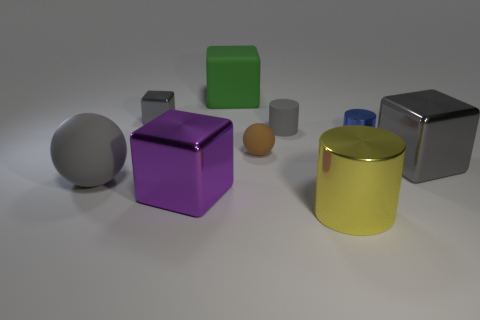Is the material of the small brown thing the same as the big gray thing right of the brown rubber thing?
Your answer should be compact. No. How big is the gray metal thing that is in front of the gray matte cylinder?
Offer a terse response. Large. Is the number of cyan shiny cylinders less than the number of large gray cubes?
Your response must be concise. Yes. Is there a tiny cylinder of the same color as the large rubber block?
Give a very brief answer. No. There is a big shiny object that is both on the left side of the tiny blue cylinder and behind the big yellow thing; what shape is it?
Make the answer very short. Cube. What is the shape of the big gray object behind the matte object that is to the left of the large green rubber cube?
Make the answer very short. Cube. Is the shape of the purple object the same as the small gray matte object?
Make the answer very short. No. What is the material of the big thing that is the same color as the big ball?
Give a very brief answer. Metal. Does the large rubber cube have the same color as the tiny block?
Your response must be concise. No. There is a large shiny cube that is left of the cylinder in front of the big matte ball; how many tiny brown things are on the left side of it?
Give a very brief answer. 0. 